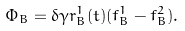Convert formula to latex. <formula><loc_0><loc_0><loc_500><loc_500>\Phi _ { B } = \delta \gamma r ^ { 1 } _ { B } ( t ) ( f ^ { 1 } _ { B } - f ^ { 2 } _ { B } ) .</formula> 